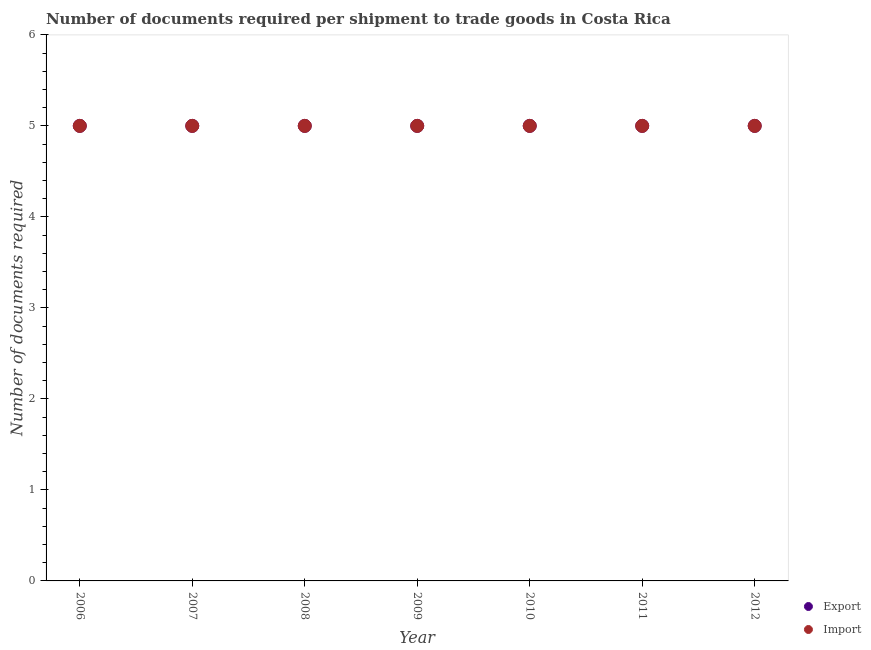What is the number of documents required to import goods in 2007?
Provide a short and direct response. 5. Across all years, what is the maximum number of documents required to export goods?
Offer a terse response. 5. Across all years, what is the minimum number of documents required to import goods?
Your answer should be very brief. 5. In which year was the number of documents required to import goods maximum?
Your answer should be very brief. 2006. In which year was the number of documents required to import goods minimum?
Give a very brief answer. 2006. What is the total number of documents required to import goods in the graph?
Make the answer very short. 35. What is the difference between the number of documents required to import goods in 2011 and the number of documents required to export goods in 2009?
Your answer should be very brief. 0. What is the ratio of the number of documents required to import goods in 2008 to that in 2011?
Give a very brief answer. 1. Is the number of documents required to export goods in 2010 less than that in 2012?
Keep it short and to the point. No. Is the difference between the number of documents required to import goods in 2008 and 2009 greater than the difference between the number of documents required to export goods in 2008 and 2009?
Provide a short and direct response. No. What is the difference between the highest and the second highest number of documents required to import goods?
Provide a succinct answer. 0. In how many years, is the number of documents required to import goods greater than the average number of documents required to import goods taken over all years?
Your answer should be compact. 0. Are the values on the major ticks of Y-axis written in scientific E-notation?
Provide a short and direct response. No. Does the graph contain any zero values?
Your answer should be compact. No. Does the graph contain grids?
Offer a very short reply. No. How many legend labels are there?
Ensure brevity in your answer.  2. How are the legend labels stacked?
Your response must be concise. Vertical. What is the title of the graph?
Offer a terse response. Number of documents required per shipment to trade goods in Costa Rica. Does "Old" appear as one of the legend labels in the graph?
Provide a succinct answer. No. What is the label or title of the Y-axis?
Provide a short and direct response. Number of documents required. What is the Number of documents required in Export in 2006?
Make the answer very short. 5. What is the Number of documents required in Import in 2006?
Your response must be concise. 5. What is the Number of documents required of Export in 2008?
Your answer should be very brief. 5. What is the Number of documents required of Import in 2009?
Make the answer very short. 5. What is the Number of documents required of Import in 2010?
Your response must be concise. 5. What is the Number of documents required in Import in 2011?
Offer a terse response. 5. What is the Number of documents required in Import in 2012?
Give a very brief answer. 5. Across all years, what is the minimum Number of documents required of Export?
Give a very brief answer. 5. What is the difference between the Number of documents required in Import in 2006 and that in 2007?
Offer a terse response. 0. What is the difference between the Number of documents required of Export in 2006 and that in 2008?
Keep it short and to the point. 0. What is the difference between the Number of documents required of Import in 2006 and that in 2008?
Offer a very short reply. 0. What is the difference between the Number of documents required of Export in 2006 and that in 2009?
Ensure brevity in your answer.  0. What is the difference between the Number of documents required in Import in 2006 and that in 2010?
Your answer should be very brief. 0. What is the difference between the Number of documents required in Import in 2006 and that in 2011?
Your response must be concise. 0. What is the difference between the Number of documents required of Import in 2006 and that in 2012?
Ensure brevity in your answer.  0. What is the difference between the Number of documents required in Import in 2007 and that in 2008?
Make the answer very short. 0. What is the difference between the Number of documents required in Import in 2007 and that in 2009?
Give a very brief answer. 0. What is the difference between the Number of documents required of Export in 2007 and that in 2010?
Offer a very short reply. 0. What is the difference between the Number of documents required of Export in 2007 and that in 2012?
Provide a short and direct response. 0. What is the difference between the Number of documents required of Export in 2008 and that in 2009?
Make the answer very short. 0. What is the difference between the Number of documents required in Import in 2008 and that in 2009?
Your answer should be very brief. 0. What is the difference between the Number of documents required in Import in 2008 and that in 2010?
Ensure brevity in your answer.  0. What is the difference between the Number of documents required in Import in 2008 and that in 2011?
Give a very brief answer. 0. What is the difference between the Number of documents required in Import in 2008 and that in 2012?
Give a very brief answer. 0. What is the difference between the Number of documents required of Export in 2009 and that in 2010?
Your response must be concise. 0. What is the difference between the Number of documents required in Import in 2009 and that in 2010?
Keep it short and to the point. 0. What is the difference between the Number of documents required of Import in 2009 and that in 2011?
Provide a short and direct response. 0. What is the difference between the Number of documents required of Export in 2009 and that in 2012?
Offer a very short reply. 0. What is the difference between the Number of documents required of Import in 2010 and that in 2011?
Offer a very short reply. 0. What is the difference between the Number of documents required of Export in 2010 and that in 2012?
Your response must be concise. 0. What is the difference between the Number of documents required of Export in 2011 and that in 2012?
Ensure brevity in your answer.  0. What is the difference between the Number of documents required in Export in 2006 and the Number of documents required in Import in 2008?
Offer a terse response. 0. What is the difference between the Number of documents required in Export in 2006 and the Number of documents required in Import in 2012?
Ensure brevity in your answer.  0. What is the difference between the Number of documents required in Export in 2007 and the Number of documents required in Import in 2012?
Make the answer very short. 0. What is the difference between the Number of documents required in Export in 2008 and the Number of documents required in Import in 2010?
Your answer should be compact. 0. What is the difference between the Number of documents required in Export in 2008 and the Number of documents required in Import in 2012?
Provide a succinct answer. 0. What is the difference between the Number of documents required of Export in 2009 and the Number of documents required of Import in 2010?
Offer a very short reply. 0. What is the difference between the Number of documents required in Export in 2009 and the Number of documents required in Import in 2012?
Make the answer very short. 0. What is the difference between the Number of documents required of Export in 2010 and the Number of documents required of Import in 2011?
Offer a terse response. 0. What is the difference between the Number of documents required of Export in 2010 and the Number of documents required of Import in 2012?
Your answer should be compact. 0. What is the difference between the Number of documents required of Export in 2011 and the Number of documents required of Import in 2012?
Make the answer very short. 0. In the year 2006, what is the difference between the Number of documents required of Export and Number of documents required of Import?
Make the answer very short. 0. In the year 2007, what is the difference between the Number of documents required of Export and Number of documents required of Import?
Provide a short and direct response. 0. In the year 2009, what is the difference between the Number of documents required of Export and Number of documents required of Import?
Give a very brief answer. 0. In the year 2010, what is the difference between the Number of documents required of Export and Number of documents required of Import?
Ensure brevity in your answer.  0. In the year 2011, what is the difference between the Number of documents required in Export and Number of documents required in Import?
Ensure brevity in your answer.  0. What is the ratio of the Number of documents required of Import in 2006 to that in 2007?
Provide a succinct answer. 1. What is the ratio of the Number of documents required in Import in 2006 to that in 2008?
Provide a succinct answer. 1. What is the ratio of the Number of documents required in Import in 2006 to that in 2009?
Offer a terse response. 1. What is the ratio of the Number of documents required in Export in 2006 to that in 2010?
Make the answer very short. 1. What is the ratio of the Number of documents required in Export in 2006 to that in 2011?
Offer a very short reply. 1. What is the ratio of the Number of documents required of Export in 2006 to that in 2012?
Offer a terse response. 1. What is the ratio of the Number of documents required of Export in 2007 to that in 2008?
Offer a terse response. 1. What is the ratio of the Number of documents required of Export in 2007 to that in 2009?
Make the answer very short. 1. What is the ratio of the Number of documents required of Export in 2007 to that in 2010?
Give a very brief answer. 1. What is the ratio of the Number of documents required in Export in 2007 to that in 2012?
Your answer should be very brief. 1. What is the ratio of the Number of documents required of Export in 2008 to that in 2011?
Your response must be concise. 1. What is the ratio of the Number of documents required in Import in 2008 to that in 2011?
Make the answer very short. 1. What is the ratio of the Number of documents required in Export in 2008 to that in 2012?
Keep it short and to the point. 1. What is the ratio of the Number of documents required in Import in 2009 to that in 2010?
Your answer should be compact. 1. What is the ratio of the Number of documents required of Import in 2009 to that in 2012?
Ensure brevity in your answer.  1. What is the ratio of the Number of documents required of Export in 2010 to that in 2011?
Your response must be concise. 1. What is the ratio of the Number of documents required in Import in 2010 to that in 2011?
Make the answer very short. 1. What is the ratio of the Number of documents required in Export in 2010 to that in 2012?
Offer a terse response. 1. What is the difference between the highest and the second highest Number of documents required of Export?
Provide a short and direct response. 0. What is the difference between the highest and the second highest Number of documents required of Import?
Your answer should be very brief. 0. What is the difference between the highest and the lowest Number of documents required of Export?
Ensure brevity in your answer.  0. 